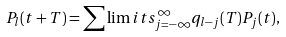<formula> <loc_0><loc_0><loc_500><loc_500>P _ { l } ( t + T ) = \sum \lim i t s _ { j = - \infty } ^ { \infty } q _ { l - j } ( T ) P _ { j } ( t ) ,</formula> 